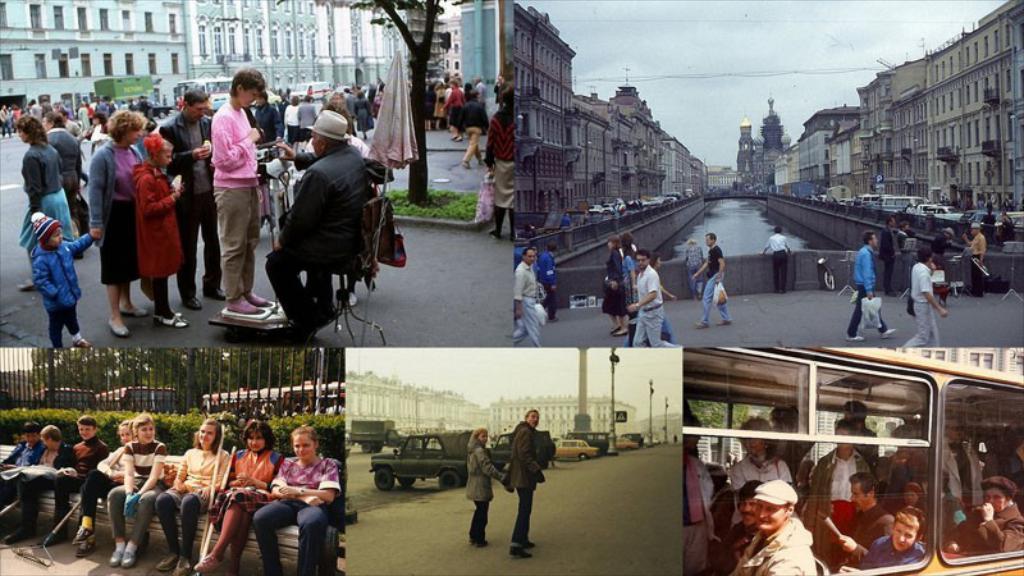In one or two sentences, can you explain what this image depicts? This is a collage picture, in this picture we can see a group of people, some people are sitting on a bench, here we can see vehicles on the road and water, fence, trees, poles and in the background we can see buildings, sky. 